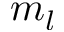Convert formula to latex. <formula><loc_0><loc_0><loc_500><loc_500>m _ { l }</formula> 